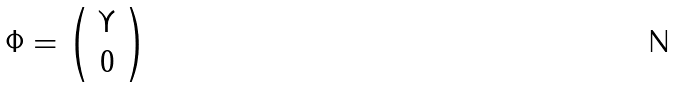<formula> <loc_0><loc_0><loc_500><loc_500>\Phi = \left ( \begin{array} { c } { \Upsilon } \\ { 0 } \end{array} \right )</formula> 